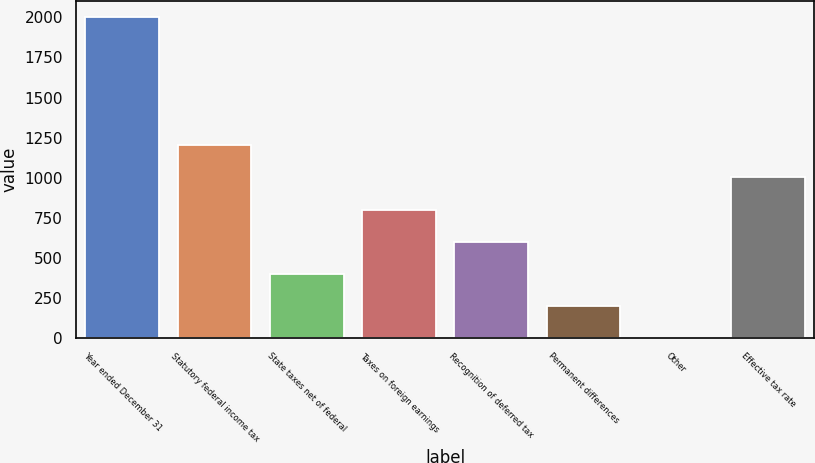<chart> <loc_0><loc_0><loc_500><loc_500><bar_chart><fcel>Year ended December 31<fcel>Statutory federal income tax<fcel>State taxes net of federal<fcel>Taxes on foreign earnings<fcel>Recognition of deferred tax<fcel>Permanent differences<fcel>Other<fcel>Effective tax rate<nl><fcel>2004<fcel>1202.64<fcel>401.28<fcel>801.96<fcel>601.62<fcel>200.94<fcel>0.6<fcel>1002.3<nl></chart> 